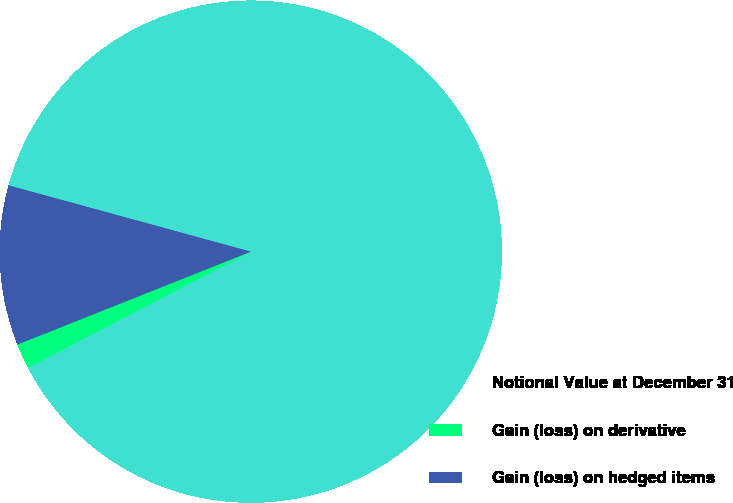<chart> <loc_0><loc_0><loc_500><loc_500><pie_chart><fcel>Notional Value at December 31<fcel>Gain (loss) on derivative<fcel>Gain (loss) on hedged items<nl><fcel>88.09%<fcel>1.63%<fcel>10.28%<nl></chart> 